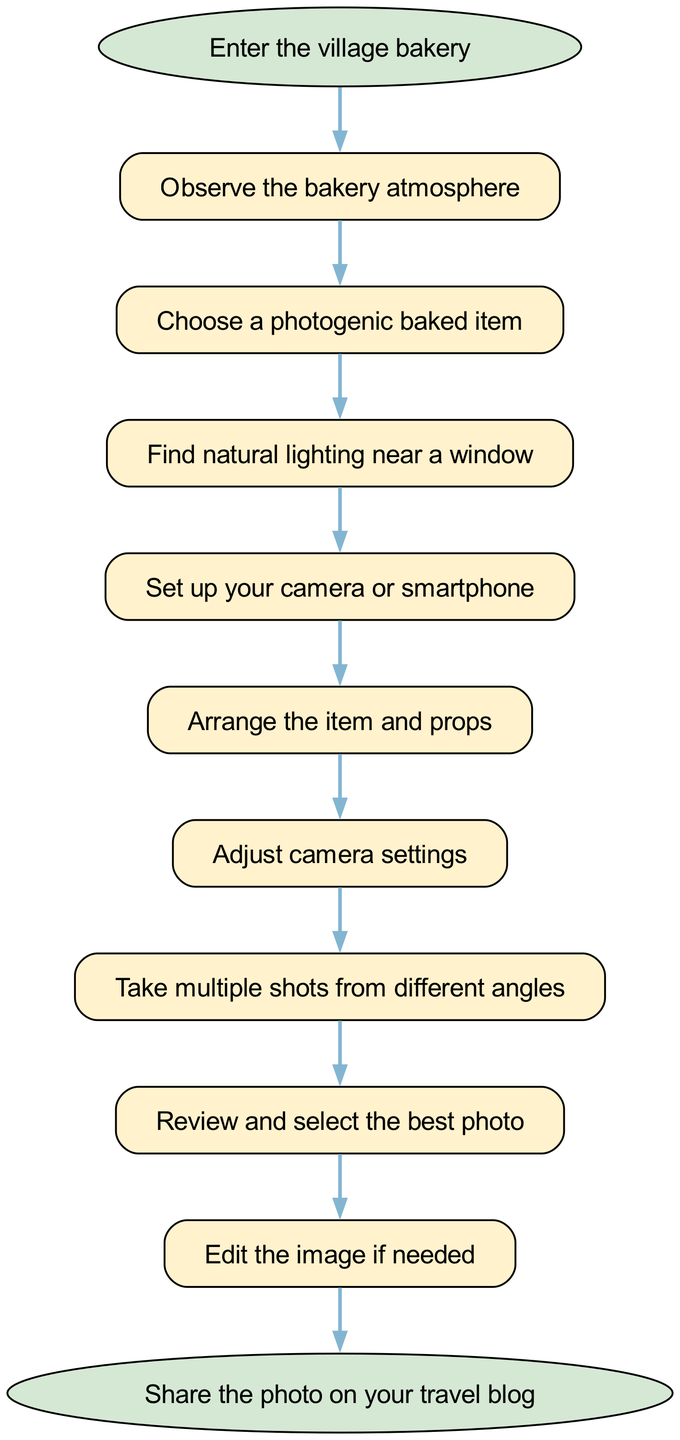What is the first step in the diagram? The first step in the diagram is labeled as "Enter the village bakery." This is clearly indicated as the starting point of the flow chart.
Answer: Enter the village bakery How many steps are there before reaching the end? There are 9 steps listed in the flow chart before the final end node is reached. These are connected sequentially from start to end.
Answer: 9 What comes after "Choose a photogenic baked item"? The step that follows "Choose a photogenic baked item" is "Find natural lighting near a window." This shows the direct flow from one action to the next in the process.
Answer: Find natural lighting near a window Which step has the camera settings adjustment? The step that involves adjusting the camera settings is "Adjust camera settings." This is explicitly stated in the sequence of steps.
Answer: Adjust camera settings How many edges connect the steps in the flowchart? There are 9 edges connecting the steps in the flowchart. Each edge represents the directional flow from one step to the next, starting from the beginning to the end.
Answer: 9 What is the last step before sharing the photo? The last step before sharing the photo is "Edit the image if needed." This step is the final action taken before completing the process.
Answer: Edit the image if needed Which step is related to the arrangement of baked items? The step related to the arrangement of baked items is "Arrange the item and props." This step focuses on the visual presentation necessary for the photograph.
Answer: Arrange the item and props What is the purpose of the "Review and select the best photo" step? The purpose of "Review and select the best photo" is to ensure that you choose the most visually appealing photograph from the multiple shots taken, which is essential for quality.
Answer: To choose the best photo 